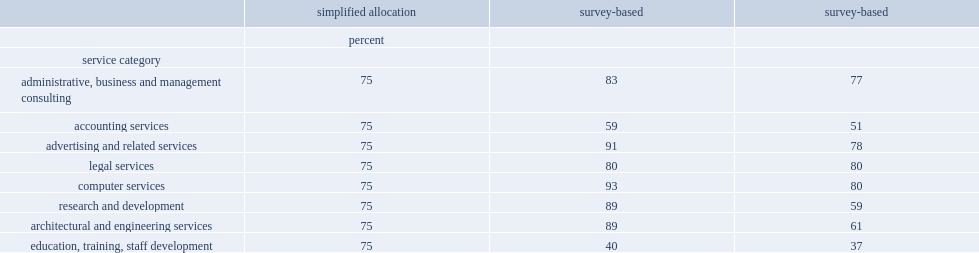What was the percent of digitally delivered are computer services upwards? 93.0. What was the share of digitally delivery were commercial education services exports were reported a maximum share? 40.0. What was the share of digitally delivery in the earlier exercise were commercial education services exports? 75.0. 